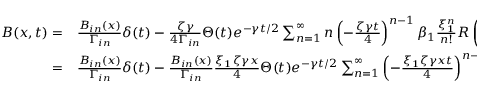Convert formula to latex. <formula><loc_0><loc_0><loc_500><loc_500>\begin{array} { r l } { B ( x , t ) = } & \frac { B _ { i n } ( x ) } { \Gamma _ { i n } } \delta ( t ) - \frac { \zeta \gamma } { 4 \Gamma _ { i n } } \Theta ( t ) e ^ { - \gamma t / 2 } \sum _ { n = 1 } ^ { \infty } n \left ( - \frac { \zeta \gamma t } { 4 } \right ) ^ { n - 1 } \beta _ { 1 } \frac { \xi _ { 1 } ^ { n } } { n ! } R \left ( \begin{array} { l } { q _ { 1 } } \\ { n + 1 } \end{array} ; x \right ) } \\ { = } & \frac { B _ { i n } ( x ) } { \Gamma _ { i n } } \delta ( t ) - \frac { B _ { i n } ( x ) } { \Gamma _ { i n } } \frac { \xi _ { 1 } \zeta \gamma x } { 4 } \Theta ( t ) e ^ { - \gamma t / 2 } \sum _ { n = 1 } ^ { \infty } \left ( - \frac { \xi _ { 1 } \zeta \gamma x t } { 4 } \right ) ^ { n - 1 } \frac { 1 } { n ! ( n - 1 ) ! } . } \end{array}</formula> 